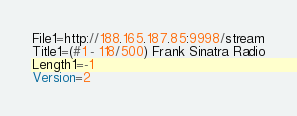<code> <loc_0><loc_0><loc_500><loc_500><_SQL_>File1=http://188.165.187.85:9998/stream
Title1=(#1 - 118/500) Frank Sinatra Radio
Length1=-1
Version=2
</code> 